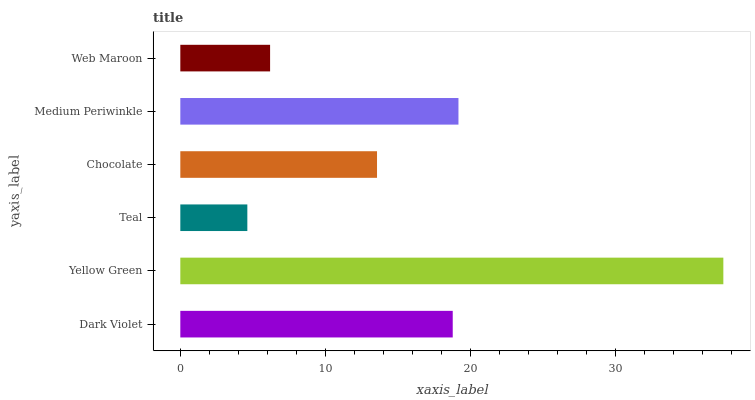Is Teal the minimum?
Answer yes or no. Yes. Is Yellow Green the maximum?
Answer yes or no. Yes. Is Yellow Green the minimum?
Answer yes or no. No. Is Teal the maximum?
Answer yes or no. No. Is Yellow Green greater than Teal?
Answer yes or no. Yes. Is Teal less than Yellow Green?
Answer yes or no. Yes. Is Teal greater than Yellow Green?
Answer yes or no. No. Is Yellow Green less than Teal?
Answer yes or no. No. Is Dark Violet the high median?
Answer yes or no. Yes. Is Chocolate the low median?
Answer yes or no. Yes. Is Yellow Green the high median?
Answer yes or no. No. Is Yellow Green the low median?
Answer yes or no. No. 